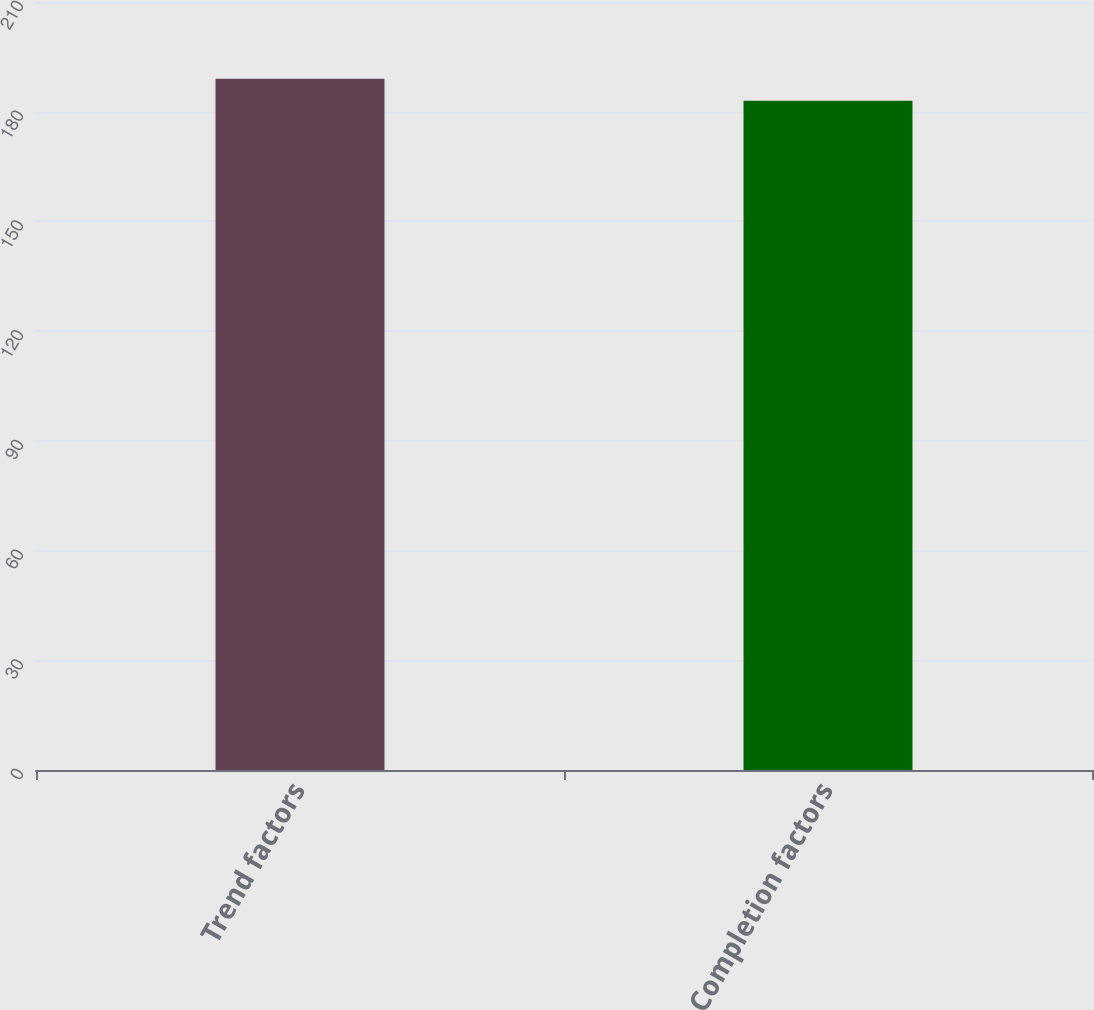Convert chart to OTSL. <chart><loc_0><loc_0><loc_500><loc_500><bar_chart><fcel>Trend factors<fcel>Completion factors<nl><fcel>189<fcel>183<nl></chart> 